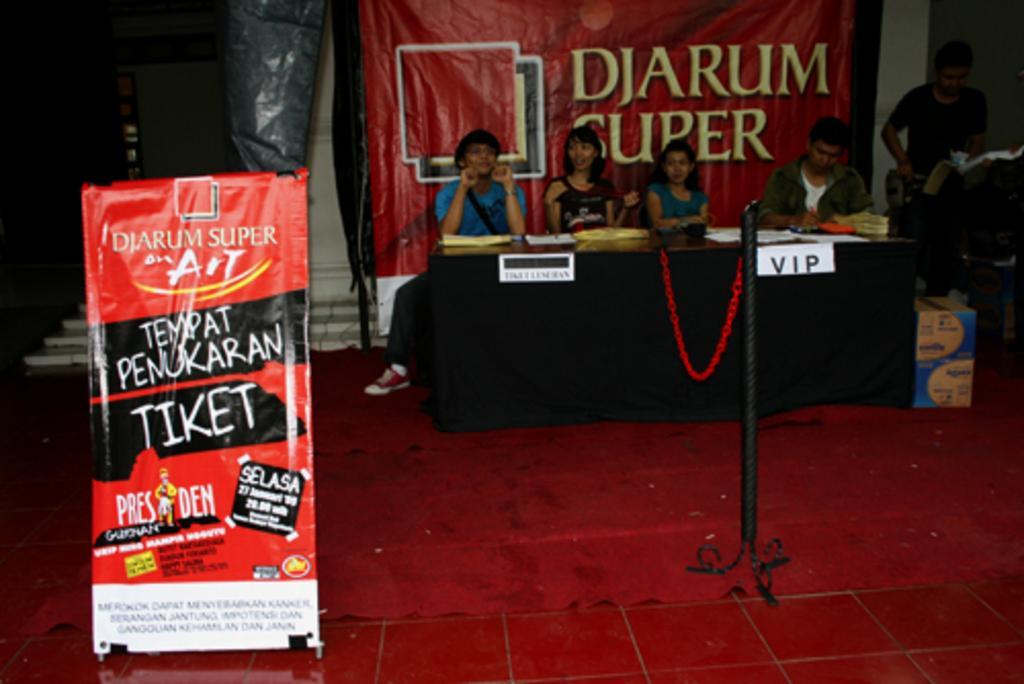Please provide a concise description of this image. In this image we can see few people sitting and one person is standing. And there is a platform. On that there are name boards and few other items. Also there is a stand. And there is a box on the floor. In the back there is a banner. On the left side there is a banner with something written. Also there are steps in the back. 